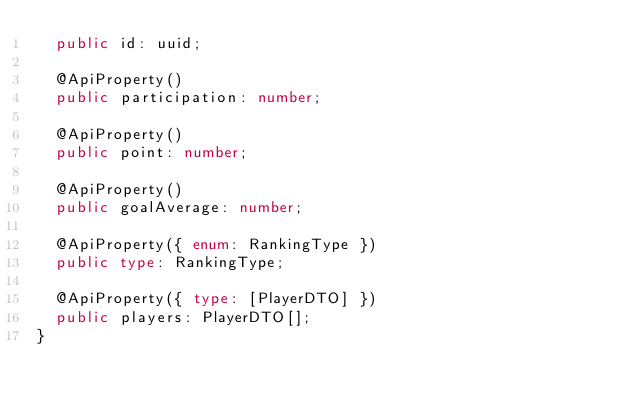Convert code to text. <code><loc_0><loc_0><loc_500><loc_500><_TypeScript_>  public id: uuid;

  @ApiProperty()
  public participation: number;

  @ApiProperty()
  public point: number;

  @ApiProperty()
  public goalAverage: number;

  @ApiProperty({ enum: RankingType })
  public type: RankingType;

  @ApiProperty({ type: [PlayerDTO] })
  public players: PlayerDTO[];
}
</code> 